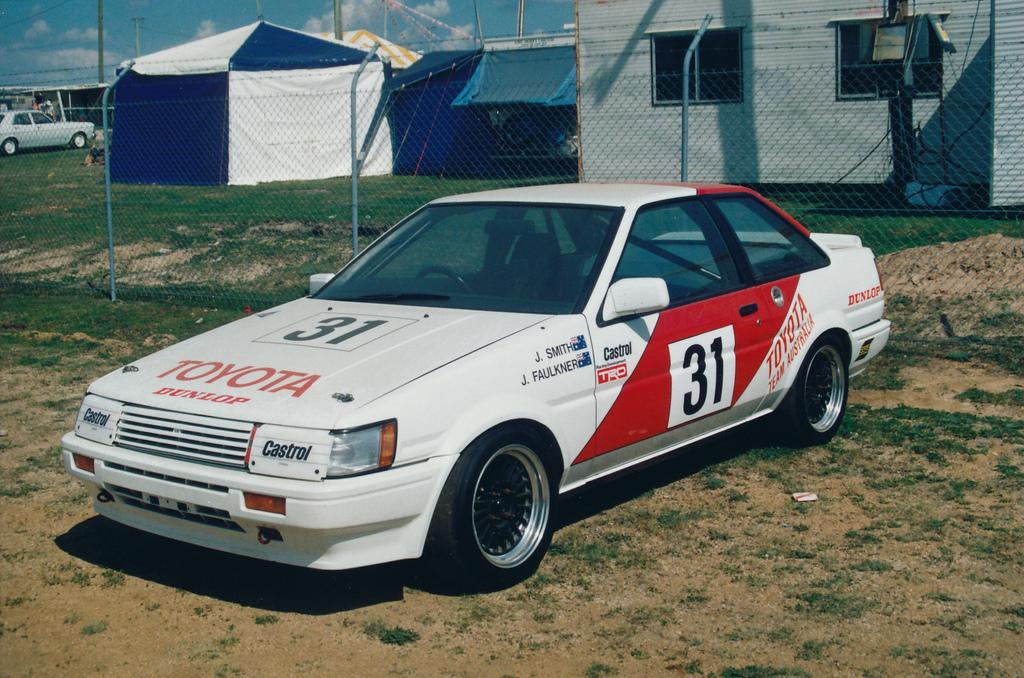What is the main subject in the foreground of the picture? There is a car in the foreground of the picture. What can be seen in the center of the picture? There is fencing in the center of the picture. What structures or objects are visible in the background of the picture? There is a tent, a canopy, a building, and other objects in the background of the picture. Are there any dinosaurs visible in the picture? No, there are no dinosaurs present in the picture. What type of airport can be seen in the background of the picture? There is no airport visible in the picture; it features a tent, canopy, building, and other objects in the background. 